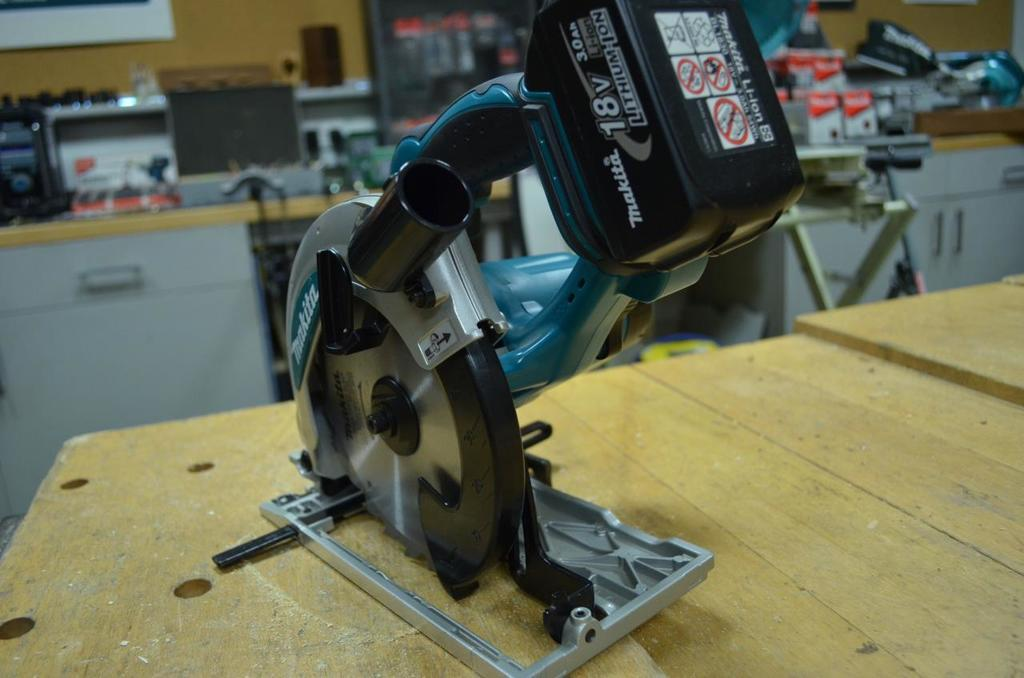What is the main subject in the image? There is a machine in the image. What is the machine resting on? The machine is on a wooden object. What can be seen in the background of the image? There are objects on a table in the background of the image. How many crows are sitting on the wall in the image? There is no wall or crows present in the image; it features a machine on a wooden object and objects on a table in the background. 